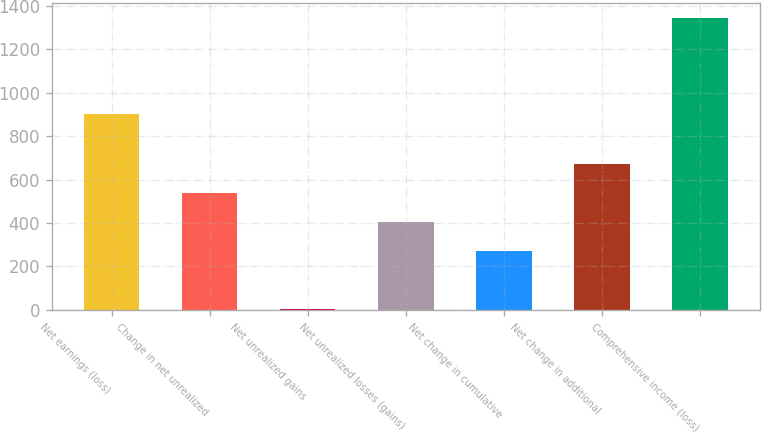<chart> <loc_0><loc_0><loc_500><loc_500><bar_chart><fcel>Net earnings (loss)<fcel>Change in net unrealized<fcel>Net unrealized gains<fcel>Net unrealized losses (gains)<fcel>Net change in cumulative<fcel>Net change in additional<fcel>Comprehensive income (loss)<nl><fcel>903<fcel>539.2<fcel>2<fcel>404.9<fcel>270.6<fcel>673.5<fcel>1345<nl></chart> 